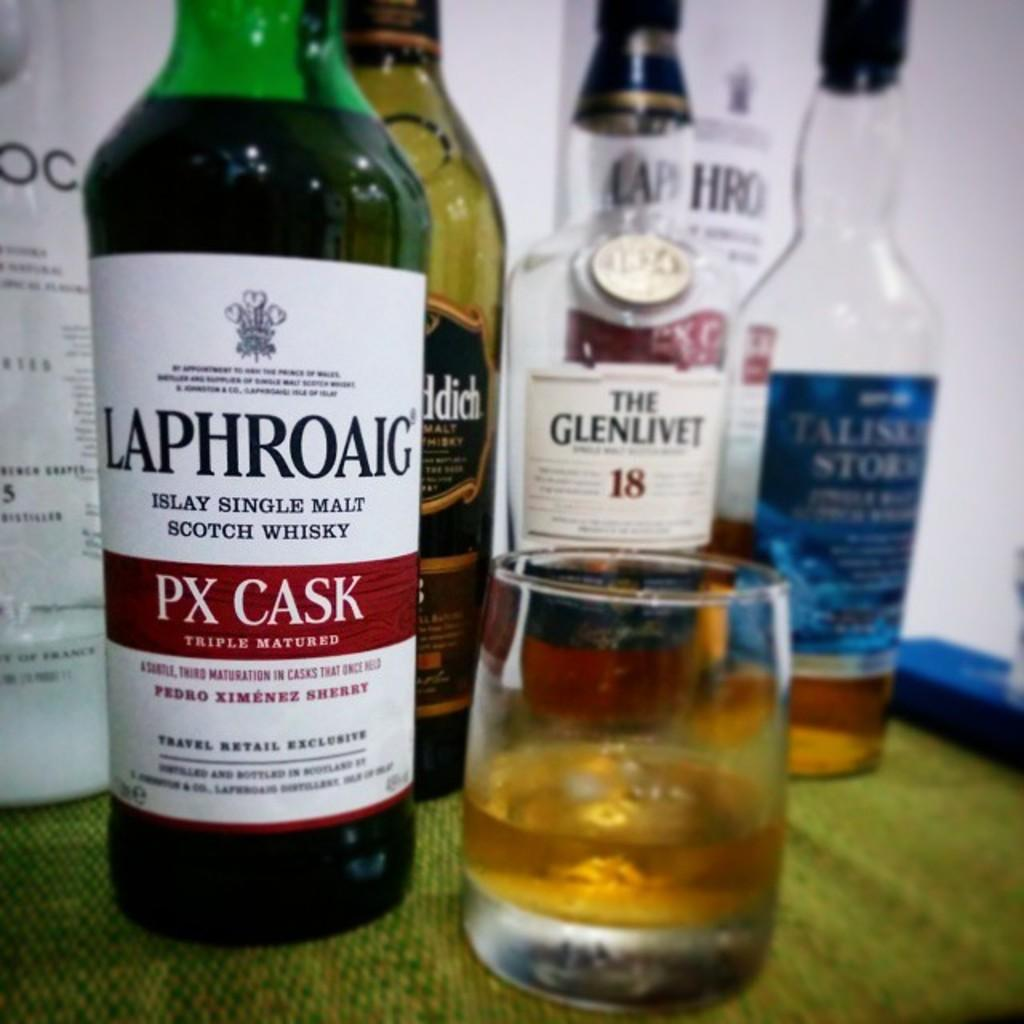<image>
Write a terse but informative summary of the picture. Bottles of alcohol with one being labeled Laphroaig with a glass next to it. 